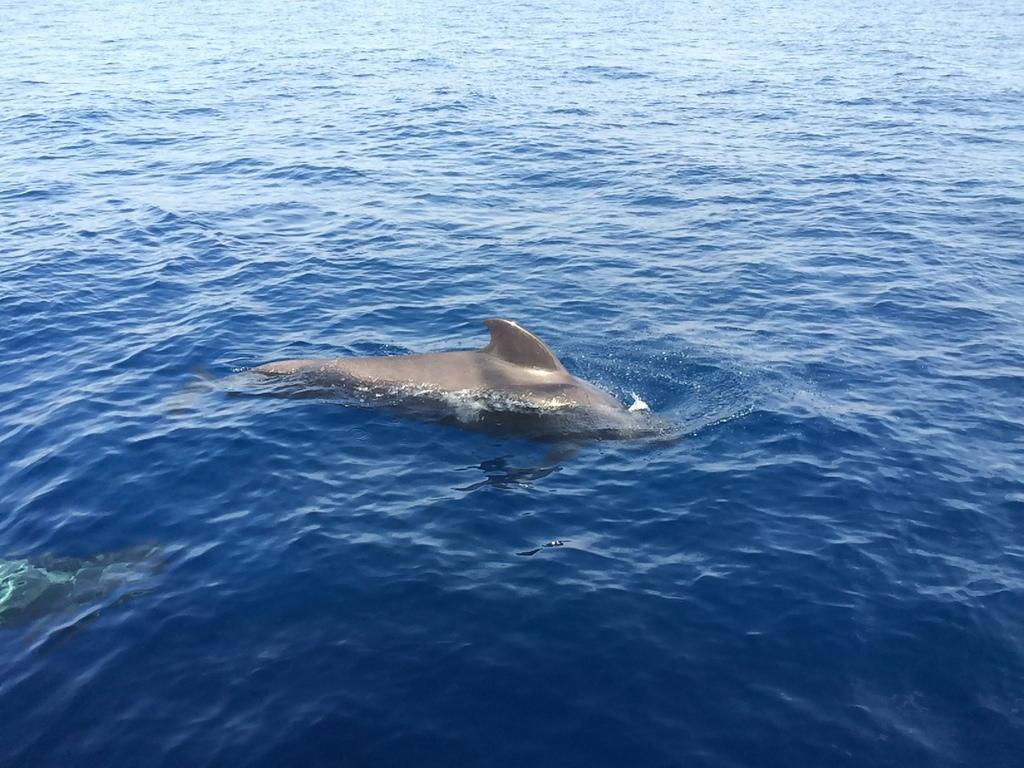What type of animal can be seen in the image? There is an aquatic animal in the image. What color is the water in the image? The water in the image is blue. What type of leaf is floating on the water in the image? There is no leaf present in the image; it only features an aquatic animal and blue water. What is the weather like in the image? The provided facts do not mention any information about the weather, so we cannot determine the weather from the image. 